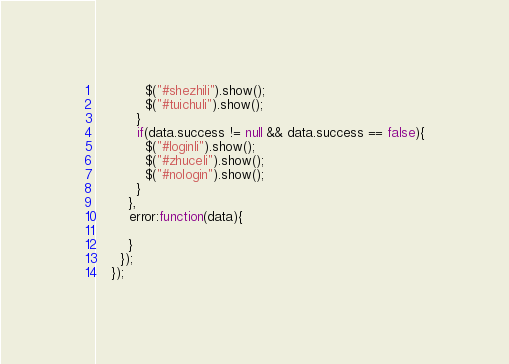Convert code to text. <code><loc_0><loc_0><loc_500><loc_500><_JavaScript_>            $("#shezhili").show();
            $("#tuichuli").show();
          }
          if(data.success != null && data.success == false){
            $("#loginli").show();
            $("#zhuceli").show();
            $("#nologin").show();
          }
        },
        error:function(data){

        }
      });
    });</code> 